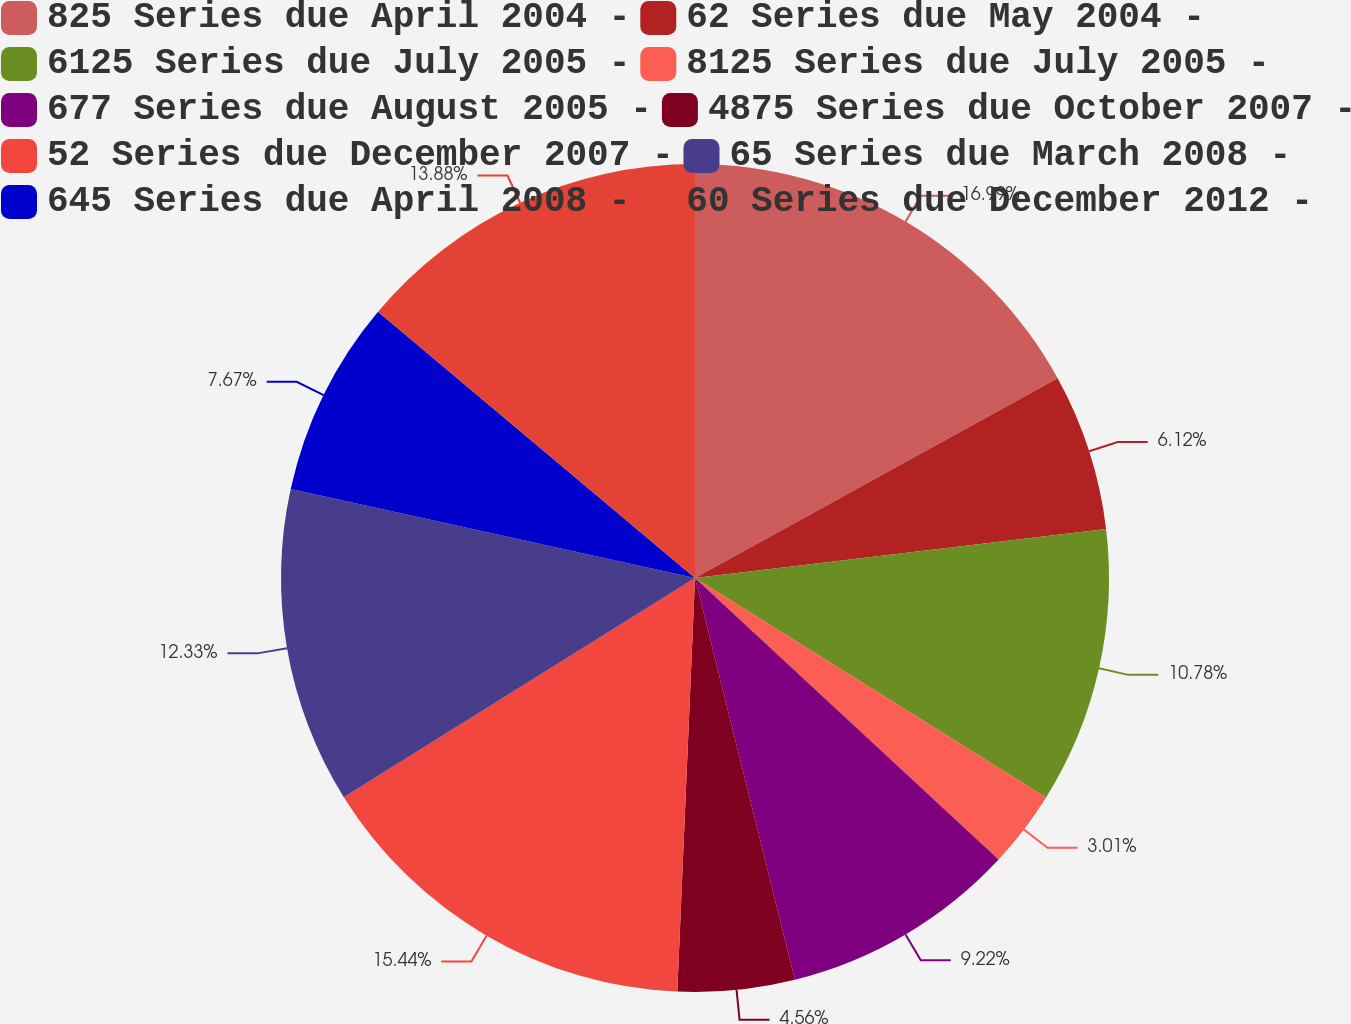<chart> <loc_0><loc_0><loc_500><loc_500><pie_chart><fcel>825 Series due April 2004 -<fcel>62 Series due May 2004 -<fcel>6125 Series due July 2005 -<fcel>8125 Series due July 2005 -<fcel>677 Series due August 2005 -<fcel>4875 Series due October 2007 -<fcel>52 Series due December 2007 -<fcel>65 Series due March 2008 -<fcel>645 Series due April 2008 -<fcel>60 Series due December 2012 -<nl><fcel>16.99%<fcel>6.12%<fcel>10.78%<fcel>3.01%<fcel>9.22%<fcel>4.56%<fcel>15.44%<fcel>12.33%<fcel>7.67%<fcel>13.88%<nl></chart> 